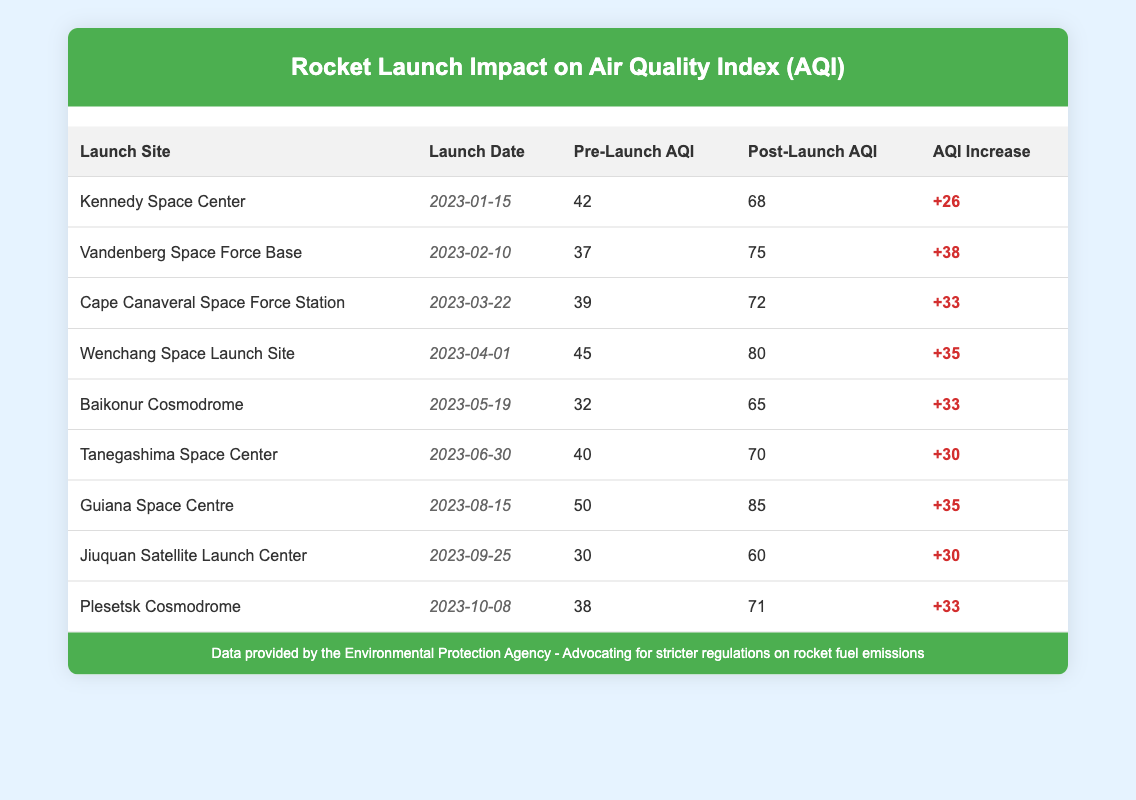What is the highest Post-Launch AQI recorded in the table? The table shows Post-Launch AQI values, and upon reviewing the values, the highest Post-Launch AQI is 85, recorded at the Guiana Space Centre.
Answer: 85 What was the Pre-Launch AQI at the Baikonur Cosmodrome? The table lists the Pre-Launch AQI for the Baikonur Cosmodrome as 32.
Answer: 32 Which launch site had the greatest increase in AQI post-launch? To find the greatest increase, we need to calculate the difference between Post-Launch and Pre-Launch AQI for each site. After examining all the increases, the greatest increase is 38, at the Vandenberg Space Force Base.
Answer: Vandenberg Space Force Base Was the Post-Launch AQI at the Tanegashima Space Center above 70? Checking the table, the Post-Launch AQI at Tanegashima is 70. Since the question asks if it is above 70, the answer is no.
Answer: No What is the average Pre-Launch AQI across all sites? To calculate the average Pre-Launch AQI, we add up all the Pre-Launch AQI values: 42 + 37 + 39 + 45 + 32 + 40 + 50 + 30 + 38 = 353. There are 9 data points, so we divide the total by 9: 353 / 9 ≈ 39.22.
Answer: Approximately 39.22 